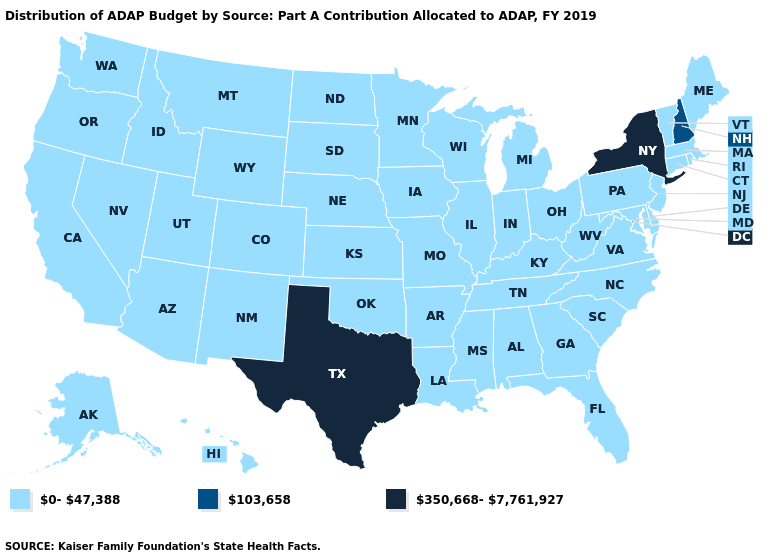Name the states that have a value in the range 103,658?
Write a very short answer. New Hampshire. Name the states that have a value in the range 350,668-7,761,927?
Answer briefly. New York, Texas. Among the states that border Michigan , which have the lowest value?
Be succinct. Indiana, Ohio, Wisconsin. What is the value of Kansas?
Answer briefly. 0-47,388. What is the value of Iowa?
Answer briefly. 0-47,388. What is the highest value in the USA?
Answer briefly. 350,668-7,761,927. What is the value of Virginia?
Short answer required. 0-47,388. What is the value of Tennessee?
Concise answer only. 0-47,388. Does Kentucky have a higher value than Wyoming?
Quick response, please. No. Among the states that border Alabama , which have the lowest value?
Answer briefly. Florida, Georgia, Mississippi, Tennessee. Does New Hampshire have the lowest value in the Northeast?
Short answer required. No. What is the value of Louisiana?
Short answer required. 0-47,388. What is the value of Indiana?
Concise answer only. 0-47,388. 